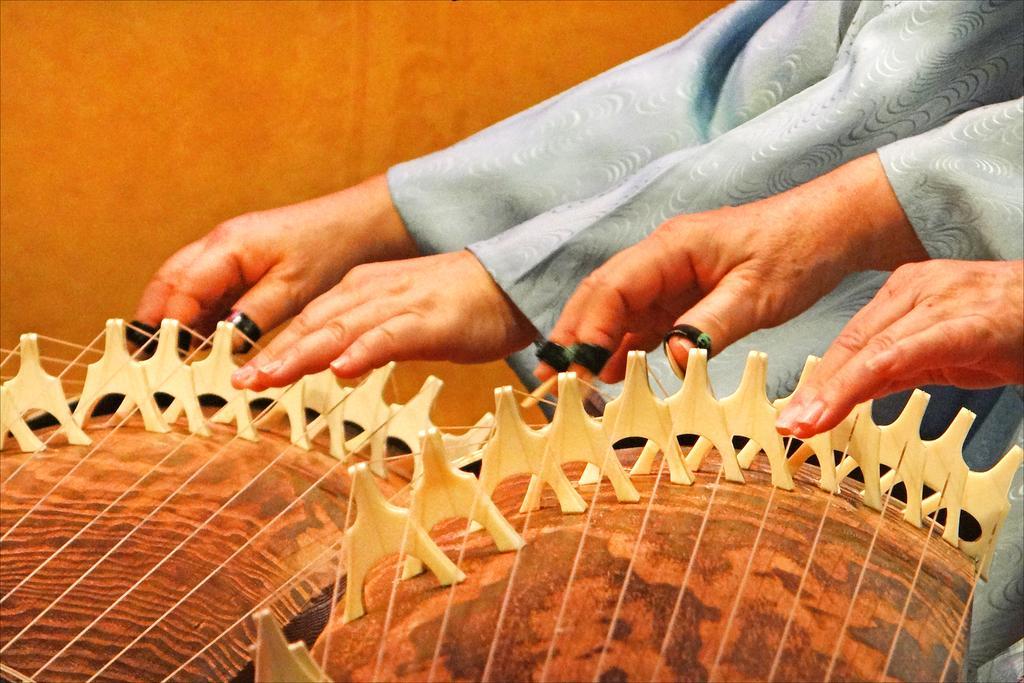Could you give a brief overview of what you see in this image? In this image I can see few people are playing the musical instruments. Background is in brown color. 